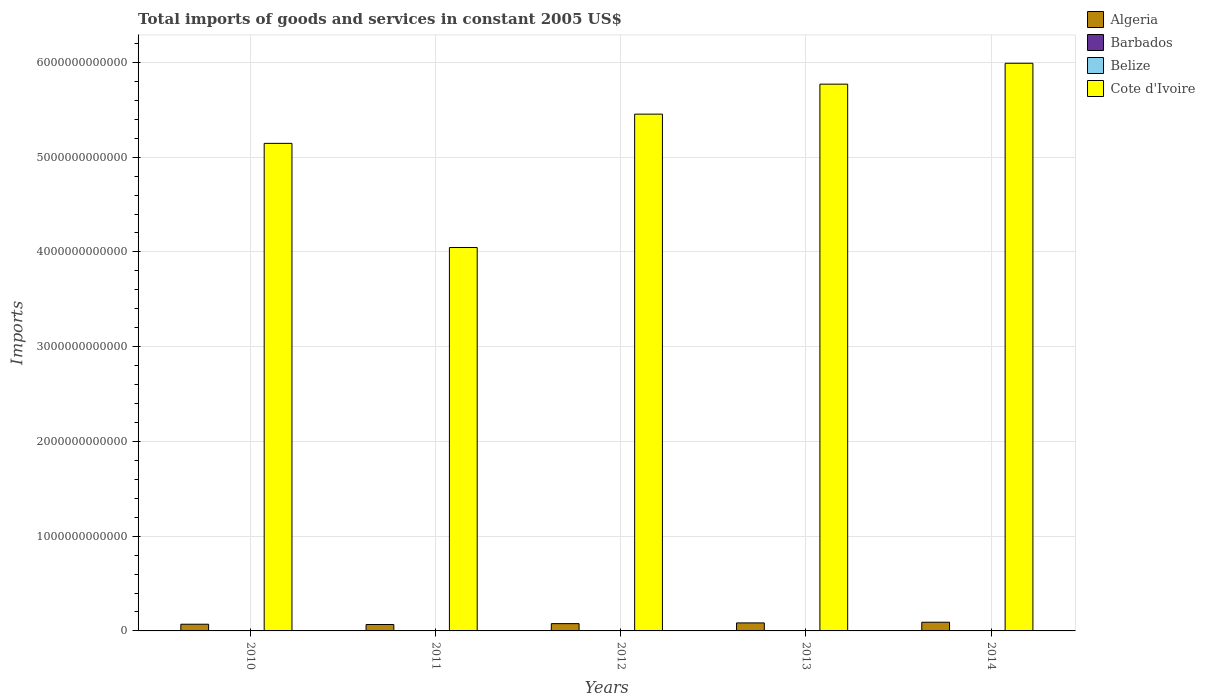How many groups of bars are there?
Keep it short and to the point. 5. Are the number of bars per tick equal to the number of legend labels?
Your answer should be very brief. Yes. Are the number of bars on each tick of the X-axis equal?
Make the answer very short. Yes. How many bars are there on the 3rd tick from the right?
Provide a succinct answer. 4. What is the label of the 5th group of bars from the left?
Your response must be concise. 2014. What is the total imports of goods and services in Algeria in 2012?
Give a very brief answer. 7.68e+1. Across all years, what is the maximum total imports of goods and services in Cote d'Ivoire?
Offer a very short reply. 5.99e+12. Across all years, what is the minimum total imports of goods and services in Barbados?
Offer a very short reply. 5.64e+08. In which year was the total imports of goods and services in Algeria maximum?
Keep it short and to the point. 2014. What is the total total imports of goods and services in Cote d'Ivoire in the graph?
Provide a succinct answer. 2.64e+13. What is the difference between the total imports of goods and services in Cote d'Ivoire in 2010 and that in 2014?
Keep it short and to the point. -8.46e+11. What is the difference between the total imports of goods and services in Algeria in 2010 and the total imports of goods and services in Barbados in 2013?
Your answer should be compact. 7.02e+1. What is the average total imports of goods and services in Algeria per year?
Keep it short and to the point. 7.83e+1. In the year 2014, what is the difference between the total imports of goods and services in Algeria and total imports of goods and services in Barbados?
Give a very brief answer. 9.12e+1. In how many years, is the total imports of goods and services in Cote d'Ivoire greater than 5800000000000 US$?
Make the answer very short. 1. What is the ratio of the total imports of goods and services in Belize in 2010 to that in 2014?
Offer a very short reply. 0.77. Is the difference between the total imports of goods and services in Algeria in 2012 and 2014 greater than the difference between the total imports of goods and services in Barbados in 2012 and 2014?
Provide a succinct answer. No. What is the difference between the highest and the second highest total imports of goods and services in Belize?
Offer a terse response. 1.65e+07. What is the difference between the highest and the lowest total imports of goods and services in Barbados?
Provide a succinct answer. 1.12e+08. In how many years, is the total imports of goods and services in Belize greater than the average total imports of goods and services in Belize taken over all years?
Ensure brevity in your answer.  2. Is it the case that in every year, the sum of the total imports of goods and services in Cote d'Ivoire and total imports of goods and services in Belize is greater than the sum of total imports of goods and services in Barbados and total imports of goods and services in Algeria?
Provide a short and direct response. Yes. What does the 1st bar from the left in 2011 represents?
Ensure brevity in your answer.  Algeria. What does the 3rd bar from the right in 2014 represents?
Provide a succinct answer. Barbados. Is it the case that in every year, the sum of the total imports of goods and services in Algeria and total imports of goods and services in Barbados is greater than the total imports of goods and services in Belize?
Provide a succinct answer. Yes. How many bars are there?
Your answer should be compact. 20. Are all the bars in the graph horizontal?
Provide a short and direct response. No. What is the difference between two consecutive major ticks on the Y-axis?
Offer a very short reply. 1.00e+12. Does the graph contain grids?
Make the answer very short. Yes. Where does the legend appear in the graph?
Provide a short and direct response. Top right. How are the legend labels stacked?
Your answer should be compact. Vertical. What is the title of the graph?
Your response must be concise. Total imports of goods and services in constant 2005 US$. What is the label or title of the X-axis?
Make the answer very short. Years. What is the label or title of the Y-axis?
Your answer should be compact. Imports. What is the Imports of Algeria in 2010?
Your answer should be very brief. 7.07e+1. What is the Imports in Barbados in 2010?
Make the answer very short. 6.76e+08. What is the Imports in Belize in 2010?
Your answer should be very brief. 1.25e+09. What is the Imports of Cote d'Ivoire in 2010?
Keep it short and to the point. 5.15e+12. What is the Imports of Algeria in 2011?
Ensure brevity in your answer.  6.75e+1. What is the Imports of Barbados in 2011?
Provide a succinct answer. 5.96e+08. What is the Imports of Belize in 2011?
Ensure brevity in your answer.  1.39e+09. What is the Imports in Cote d'Ivoire in 2011?
Provide a short and direct response. 4.05e+12. What is the Imports in Algeria in 2012?
Offer a very short reply. 7.68e+1. What is the Imports of Barbados in 2012?
Make the answer very short. 5.68e+08. What is the Imports of Belize in 2012?
Ensure brevity in your answer.  1.45e+09. What is the Imports in Cote d'Ivoire in 2012?
Make the answer very short. 5.45e+12. What is the Imports in Algeria in 2013?
Keep it short and to the point. 8.45e+1. What is the Imports of Barbados in 2013?
Your answer should be very brief. 5.64e+08. What is the Imports of Belize in 2013?
Your answer should be very brief. 1.60e+09. What is the Imports of Cote d'Ivoire in 2013?
Your answer should be very brief. 5.77e+12. What is the Imports in Algeria in 2014?
Keep it short and to the point. 9.18e+1. What is the Imports of Barbados in 2014?
Your response must be concise. 5.75e+08. What is the Imports of Belize in 2014?
Your response must be concise. 1.61e+09. What is the Imports of Cote d'Ivoire in 2014?
Provide a succinct answer. 5.99e+12. Across all years, what is the maximum Imports in Algeria?
Offer a terse response. 9.18e+1. Across all years, what is the maximum Imports of Barbados?
Ensure brevity in your answer.  6.76e+08. Across all years, what is the maximum Imports in Belize?
Keep it short and to the point. 1.61e+09. Across all years, what is the maximum Imports of Cote d'Ivoire?
Make the answer very short. 5.99e+12. Across all years, what is the minimum Imports of Algeria?
Offer a very short reply. 6.75e+1. Across all years, what is the minimum Imports in Barbados?
Give a very brief answer. 5.64e+08. Across all years, what is the minimum Imports of Belize?
Keep it short and to the point. 1.25e+09. Across all years, what is the minimum Imports of Cote d'Ivoire?
Your answer should be very brief. 4.05e+12. What is the total Imports in Algeria in the graph?
Your answer should be very brief. 3.91e+11. What is the total Imports of Barbados in the graph?
Your answer should be compact. 2.98e+09. What is the total Imports in Belize in the graph?
Your answer should be very brief. 7.30e+09. What is the total Imports in Cote d'Ivoire in the graph?
Give a very brief answer. 2.64e+13. What is the difference between the Imports of Algeria in 2010 and that in 2011?
Provide a short and direct response. 3.25e+09. What is the difference between the Imports of Barbados in 2010 and that in 2011?
Offer a very short reply. 8.00e+07. What is the difference between the Imports of Belize in 2010 and that in 2011?
Offer a terse response. -1.47e+08. What is the difference between the Imports in Cote d'Ivoire in 2010 and that in 2011?
Give a very brief answer. 1.10e+12. What is the difference between the Imports in Algeria in 2010 and that in 2012?
Your answer should be compact. -6.12e+09. What is the difference between the Imports of Barbados in 2010 and that in 2012?
Your answer should be compact. 1.08e+08. What is the difference between the Imports in Belize in 2010 and that in 2012?
Your answer should be very brief. -2.09e+08. What is the difference between the Imports of Cote d'Ivoire in 2010 and that in 2012?
Give a very brief answer. -3.09e+11. What is the difference between the Imports of Algeria in 2010 and that in 2013?
Keep it short and to the point. -1.38e+1. What is the difference between the Imports in Barbados in 2010 and that in 2013?
Provide a succinct answer. 1.12e+08. What is the difference between the Imports in Belize in 2010 and that in 2013?
Offer a terse response. -3.49e+08. What is the difference between the Imports in Cote d'Ivoire in 2010 and that in 2013?
Your response must be concise. -6.25e+11. What is the difference between the Imports of Algeria in 2010 and that in 2014?
Offer a terse response. -2.11e+1. What is the difference between the Imports of Barbados in 2010 and that in 2014?
Keep it short and to the point. 1.01e+08. What is the difference between the Imports of Belize in 2010 and that in 2014?
Your answer should be very brief. -3.66e+08. What is the difference between the Imports of Cote d'Ivoire in 2010 and that in 2014?
Your answer should be very brief. -8.46e+11. What is the difference between the Imports of Algeria in 2011 and that in 2012?
Provide a short and direct response. -9.38e+09. What is the difference between the Imports of Barbados in 2011 and that in 2012?
Your answer should be compact. 2.80e+07. What is the difference between the Imports of Belize in 2011 and that in 2012?
Your answer should be very brief. -6.25e+07. What is the difference between the Imports of Cote d'Ivoire in 2011 and that in 2012?
Your response must be concise. -1.41e+12. What is the difference between the Imports of Algeria in 2011 and that in 2013?
Provide a short and direct response. -1.71e+1. What is the difference between the Imports in Barbados in 2011 and that in 2013?
Ensure brevity in your answer.  3.20e+07. What is the difference between the Imports of Belize in 2011 and that in 2013?
Offer a terse response. -2.03e+08. What is the difference between the Imports of Cote d'Ivoire in 2011 and that in 2013?
Offer a terse response. -1.72e+12. What is the difference between the Imports in Algeria in 2011 and that in 2014?
Your response must be concise. -2.43e+1. What is the difference between the Imports in Barbados in 2011 and that in 2014?
Keep it short and to the point. 2.10e+07. What is the difference between the Imports of Belize in 2011 and that in 2014?
Your answer should be compact. -2.19e+08. What is the difference between the Imports in Cote d'Ivoire in 2011 and that in 2014?
Make the answer very short. -1.94e+12. What is the difference between the Imports in Algeria in 2012 and that in 2013?
Offer a very short reply. -7.68e+09. What is the difference between the Imports of Barbados in 2012 and that in 2013?
Offer a terse response. 4.00e+06. What is the difference between the Imports in Belize in 2012 and that in 2013?
Offer a very short reply. -1.40e+08. What is the difference between the Imports in Cote d'Ivoire in 2012 and that in 2013?
Provide a succinct answer. -3.16e+11. What is the difference between the Imports in Algeria in 2012 and that in 2014?
Provide a succinct answer. -1.50e+1. What is the difference between the Imports of Barbados in 2012 and that in 2014?
Offer a terse response. -7.00e+06. What is the difference between the Imports of Belize in 2012 and that in 2014?
Offer a very short reply. -1.57e+08. What is the difference between the Imports in Cote d'Ivoire in 2012 and that in 2014?
Provide a succinct answer. -5.37e+11. What is the difference between the Imports in Algeria in 2013 and that in 2014?
Make the answer very short. -7.27e+09. What is the difference between the Imports of Barbados in 2013 and that in 2014?
Your response must be concise. -1.10e+07. What is the difference between the Imports in Belize in 2013 and that in 2014?
Make the answer very short. -1.65e+07. What is the difference between the Imports in Cote d'Ivoire in 2013 and that in 2014?
Your response must be concise. -2.21e+11. What is the difference between the Imports in Algeria in 2010 and the Imports in Barbados in 2011?
Offer a terse response. 7.01e+1. What is the difference between the Imports of Algeria in 2010 and the Imports of Belize in 2011?
Make the answer very short. 6.93e+1. What is the difference between the Imports in Algeria in 2010 and the Imports in Cote d'Ivoire in 2011?
Offer a terse response. -3.98e+12. What is the difference between the Imports of Barbados in 2010 and the Imports of Belize in 2011?
Offer a terse response. -7.16e+08. What is the difference between the Imports in Barbados in 2010 and the Imports in Cote d'Ivoire in 2011?
Your answer should be compact. -4.05e+12. What is the difference between the Imports in Belize in 2010 and the Imports in Cote d'Ivoire in 2011?
Offer a very short reply. -4.05e+12. What is the difference between the Imports of Algeria in 2010 and the Imports of Barbados in 2012?
Make the answer very short. 7.02e+1. What is the difference between the Imports of Algeria in 2010 and the Imports of Belize in 2012?
Your response must be concise. 6.93e+1. What is the difference between the Imports in Algeria in 2010 and the Imports in Cote d'Ivoire in 2012?
Your answer should be very brief. -5.38e+12. What is the difference between the Imports in Barbados in 2010 and the Imports in Belize in 2012?
Offer a terse response. -7.79e+08. What is the difference between the Imports of Barbados in 2010 and the Imports of Cote d'Ivoire in 2012?
Make the answer very short. -5.45e+12. What is the difference between the Imports of Belize in 2010 and the Imports of Cote d'Ivoire in 2012?
Your response must be concise. -5.45e+12. What is the difference between the Imports in Algeria in 2010 and the Imports in Barbados in 2013?
Keep it short and to the point. 7.02e+1. What is the difference between the Imports of Algeria in 2010 and the Imports of Belize in 2013?
Offer a very short reply. 6.91e+1. What is the difference between the Imports of Algeria in 2010 and the Imports of Cote d'Ivoire in 2013?
Your answer should be compact. -5.70e+12. What is the difference between the Imports in Barbados in 2010 and the Imports in Belize in 2013?
Your response must be concise. -9.19e+08. What is the difference between the Imports of Barbados in 2010 and the Imports of Cote d'Ivoire in 2013?
Your response must be concise. -5.77e+12. What is the difference between the Imports in Belize in 2010 and the Imports in Cote d'Ivoire in 2013?
Provide a short and direct response. -5.77e+12. What is the difference between the Imports in Algeria in 2010 and the Imports in Barbados in 2014?
Keep it short and to the point. 7.01e+1. What is the difference between the Imports of Algeria in 2010 and the Imports of Belize in 2014?
Your answer should be very brief. 6.91e+1. What is the difference between the Imports of Algeria in 2010 and the Imports of Cote d'Ivoire in 2014?
Your answer should be very brief. -5.92e+12. What is the difference between the Imports in Barbados in 2010 and the Imports in Belize in 2014?
Offer a very short reply. -9.36e+08. What is the difference between the Imports in Barbados in 2010 and the Imports in Cote d'Ivoire in 2014?
Your answer should be very brief. -5.99e+12. What is the difference between the Imports of Belize in 2010 and the Imports of Cote d'Ivoire in 2014?
Your answer should be very brief. -5.99e+12. What is the difference between the Imports in Algeria in 2011 and the Imports in Barbados in 2012?
Provide a succinct answer. 6.69e+1. What is the difference between the Imports of Algeria in 2011 and the Imports of Belize in 2012?
Offer a terse response. 6.60e+1. What is the difference between the Imports of Algeria in 2011 and the Imports of Cote d'Ivoire in 2012?
Offer a terse response. -5.39e+12. What is the difference between the Imports in Barbados in 2011 and the Imports in Belize in 2012?
Keep it short and to the point. -8.59e+08. What is the difference between the Imports in Barbados in 2011 and the Imports in Cote d'Ivoire in 2012?
Give a very brief answer. -5.45e+12. What is the difference between the Imports of Belize in 2011 and the Imports of Cote d'Ivoire in 2012?
Give a very brief answer. -5.45e+12. What is the difference between the Imports of Algeria in 2011 and the Imports of Barbados in 2013?
Keep it short and to the point. 6.69e+1. What is the difference between the Imports in Algeria in 2011 and the Imports in Belize in 2013?
Ensure brevity in your answer.  6.59e+1. What is the difference between the Imports of Algeria in 2011 and the Imports of Cote d'Ivoire in 2013?
Offer a terse response. -5.70e+12. What is the difference between the Imports in Barbados in 2011 and the Imports in Belize in 2013?
Your answer should be very brief. -9.99e+08. What is the difference between the Imports of Barbados in 2011 and the Imports of Cote d'Ivoire in 2013?
Your response must be concise. -5.77e+12. What is the difference between the Imports of Belize in 2011 and the Imports of Cote d'Ivoire in 2013?
Give a very brief answer. -5.77e+12. What is the difference between the Imports of Algeria in 2011 and the Imports of Barbados in 2014?
Your answer should be very brief. 6.69e+1. What is the difference between the Imports in Algeria in 2011 and the Imports in Belize in 2014?
Provide a short and direct response. 6.59e+1. What is the difference between the Imports of Algeria in 2011 and the Imports of Cote d'Ivoire in 2014?
Ensure brevity in your answer.  -5.92e+12. What is the difference between the Imports of Barbados in 2011 and the Imports of Belize in 2014?
Give a very brief answer. -1.02e+09. What is the difference between the Imports of Barbados in 2011 and the Imports of Cote d'Ivoire in 2014?
Give a very brief answer. -5.99e+12. What is the difference between the Imports in Belize in 2011 and the Imports in Cote d'Ivoire in 2014?
Make the answer very short. -5.99e+12. What is the difference between the Imports of Algeria in 2012 and the Imports of Barbados in 2013?
Offer a very short reply. 7.63e+1. What is the difference between the Imports of Algeria in 2012 and the Imports of Belize in 2013?
Your response must be concise. 7.52e+1. What is the difference between the Imports in Algeria in 2012 and the Imports in Cote d'Ivoire in 2013?
Offer a very short reply. -5.69e+12. What is the difference between the Imports of Barbados in 2012 and the Imports of Belize in 2013?
Your answer should be very brief. -1.03e+09. What is the difference between the Imports in Barbados in 2012 and the Imports in Cote d'Ivoire in 2013?
Make the answer very short. -5.77e+12. What is the difference between the Imports in Belize in 2012 and the Imports in Cote d'Ivoire in 2013?
Offer a terse response. -5.77e+12. What is the difference between the Imports of Algeria in 2012 and the Imports of Barbados in 2014?
Provide a short and direct response. 7.63e+1. What is the difference between the Imports in Algeria in 2012 and the Imports in Belize in 2014?
Your answer should be compact. 7.52e+1. What is the difference between the Imports of Algeria in 2012 and the Imports of Cote d'Ivoire in 2014?
Your response must be concise. -5.91e+12. What is the difference between the Imports in Barbados in 2012 and the Imports in Belize in 2014?
Offer a terse response. -1.04e+09. What is the difference between the Imports in Barbados in 2012 and the Imports in Cote d'Ivoire in 2014?
Provide a short and direct response. -5.99e+12. What is the difference between the Imports of Belize in 2012 and the Imports of Cote d'Ivoire in 2014?
Your answer should be very brief. -5.99e+12. What is the difference between the Imports in Algeria in 2013 and the Imports in Barbados in 2014?
Your answer should be compact. 8.40e+1. What is the difference between the Imports in Algeria in 2013 and the Imports in Belize in 2014?
Ensure brevity in your answer.  8.29e+1. What is the difference between the Imports of Algeria in 2013 and the Imports of Cote d'Ivoire in 2014?
Keep it short and to the point. -5.91e+12. What is the difference between the Imports of Barbados in 2013 and the Imports of Belize in 2014?
Your answer should be compact. -1.05e+09. What is the difference between the Imports of Barbados in 2013 and the Imports of Cote d'Ivoire in 2014?
Provide a succinct answer. -5.99e+12. What is the difference between the Imports in Belize in 2013 and the Imports in Cote d'Ivoire in 2014?
Offer a terse response. -5.99e+12. What is the average Imports of Algeria per year?
Your response must be concise. 7.83e+1. What is the average Imports in Barbados per year?
Offer a terse response. 5.96e+08. What is the average Imports in Belize per year?
Provide a succinct answer. 1.46e+09. What is the average Imports of Cote d'Ivoire per year?
Your answer should be very brief. 5.28e+12. In the year 2010, what is the difference between the Imports of Algeria and Imports of Barbados?
Provide a short and direct response. 7.00e+1. In the year 2010, what is the difference between the Imports of Algeria and Imports of Belize?
Your answer should be compact. 6.95e+1. In the year 2010, what is the difference between the Imports of Algeria and Imports of Cote d'Ivoire?
Your answer should be very brief. -5.07e+12. In the year 2010, what is the difference between the Imports in Barbados and Imports in Belize?
Your answer should be compact. -5.70e+08. In the year 2010, what is the difference between the Imports of Barbados and Imports of Cote d'Ivoire?
Offer a very short reply. -5.14e+12. In the year 2010, what is the difference between the Imports in Belize and Imports in Cote d'Ivoire?
Offer a terse response. -5.14e+12. In the year 2011, what is the difference between the Imports in Algeria and Imports in Barbados?
Offer a terse response. 6.69e+1. In the year 2011, what is the difference between the Imports of Algeria and Imports of Belize?
Keep it short and to the point. 6.61e+1. In the year 2011, what is the difference between the Imports of Algeria and Imports of Cote d'Ivoire?
Provide a short and direct response. -3.98e+12. In the year 2011, what is the difference between the Imports of Barbados and Imports of Belize?
Offer a very short reply. -7.96e+08. In the year 2011, what is the difference between the Imports of Barbados and Imports of Cote d'Ivoire?
Offer a very short reply. -4.05e+12. In the year 2011, what is the difference between the Imports in Belize and Imports in Cote d'Ivoire?
Your answer should be compact. -4.04e+12. In the year 2012, what is the difference between the Imports in Algeria and Imports in Barbados?
Your response must be concise. 7.63e+1. In the year 2012, what is the difference between the Imports of Algeria and Imports of Belize?
Ensure brevity in your answer.  7.54e+1. In the year 2012, what is the difference between the Imports in Algeria and Imports in Cote d'Ivoire?
Offer a terse response. -5.38e+12. In the year 2012, what is the difference between the Imports in Barbados and Imports in Belize?
Give a very brief answer. -8.87e+08. In the year 2012, what is the difference between the Imports in Barbados and Imports in Cote d'Ivoire?
Provide a short and direct response. -5.45e+12. In the year 2012, what is the difference between the Imports in Belize and Imports in Cote d'Ivoire?
Provide a succinct answer. -5.45e+12. In the year 2013, what is the difference between the Imports of Algeria and Imports of Barbados?
Provide a succinct answer. 8.40e+1. In the year 2013, what is the difference between the Imports in Algeria and Imports in Belize?
Your answer should be compact. 8.29e+1. In the year 2013, what is the difference between the Imports in Algeria and Imports in Cote d'Ivoire?
Make the answer very short. -5.69e+12. In the year 2013, what is the difference between the Imports of Barbados and Imports of Belize?
Your answer should be compact. -1.03e+09. In the year 2013, what is the difference between the Imports in Barbados and Imports in Cote d'Ivoire?
Ensure brevity in your answer.  -5.77e+12. In the year 2013, what is the difference between the Imports of Belize and Imports of Cote d'Ivoire?
Offer a very short reply. -5.77e+12. In the year 2014, what is the difference between the Imports of Algeria and Imports of Barbados?
Offer a very short reply. 9.12e+1. In the year 2014, what is the difference between the Imports in Algeria and Imports in Belize?
Give a very brief answer. 9.02e+1. In the year 2014, what is the difference between the Imports in Algeria and Imports in Cote d'Ivoire?
Your answer should be compact. -5.90e+12. In the year 2014, what is the difference between the Imports of Barbados and Imports of Belize?
Your answer should be very brief. -1.04e+09. In the year 2014, what is the difference between the Imports of Barbados and Imports of Cote d'Ivoire?
Offer a terse response. -5.99e+12. In the year 2014, what is the difference between the Imports of Belize and Imports of Cote d'Ivoire?
Provide a succinct answer. -5.99e+12. What is the ratio of the Imports in Algeria in 2010 to that in 2011?
Keep it short and to the point. 1.05. What is the ratio of the Imports of Barbados in 2010 to that in 2011?
Ensure brevity in your answer.  1.13. What is the ratio of the Imports in Belize in 2010 to that in 2011?
Your response must be concise. 0.89. What is the ratio of the Imports in Cote d'Ivoire in 2010 to that in 2011?
Make the answer very short. 1.27. What is the ratio of the Imports in Algeria in 2010 to that in 2012?
Make the answer very short. 0.92. What is the ratio of the Imports in Barbados in 2010 to that in 2012?
Your answer should be compact. 1.19. What is the ratio of the Imports in Belize in 2010 to that in 2012?
Offer a terse response. 0.86. What is the ratio of the Imports in Cote d'Ivoire in 2010 to that in 2012?
Offer a terse response. 0.94. What is the ratio of the Imports of Algeria in 2010 to that in 2013?
Make the answer very short. 0.84. What is the ratio of the Imports in Barbados in 2010 to that in 2013?
Give a very brief answer. 1.2. What is the ratio of the Imports in Belize in 2010 to that in 2013?
Offer a terse response. 0.78. What is the ratio of the Imports of Cote d'Ivoire in 2010 to that in 2013?
Offer a terse response. 0.89. What is the ratio of the Imports of Algeria in 2010 to that in 2014?
Give a very brief answer. 0.77. What is the ratio of the Imports of Barbados in 2010 to that in 2014?
Provide a succinct answer. 1.18. What is the ratio of the Imports of Belize in 2010 to that in 2014?
Provide a succinct answer. 0.77. What is the ratio of the Imports of Cote d'Ivoire in 2010 to that in 2014?
Give a very brief answer. 0.86. What is the ratio of the Imports of Algeria in 2011 to that in 2012?
Offer a very short reply. 0.88. What is the ratio of the Imports of Barbados in 2011 to that in 2012?
Give a very brief answer. 1.05. What is the ratio of the Imports in Belize in 2011 to that in 2012?
Give a very brief answer. 0.96. What is the ratio of the Imports of Cote d'Ivoire in 2011 to that in 2012?
Give a very brief answer. 0.74. What is the ratio of the Imports of Algeria in 2011 to that in 2013?
Provide a short and direct response. 0.8. What is the ratio of the Imports in Barbados in 2011 to that in 2013?
Your answer should be very brief. 1.06. What is the ratio of the Imports in Belize in 2011 to that in 2013?
Give a very brief answer. 0.87. What is the ratio of the Imports in Cote d'Ivoire in 2011 to that in 2013?
Offer a very short reply. 0.7. What is the ratio of the Imports in Algeria in 2011 to that in 2014?
Provide a short and direct response. 0.73. What is the ratio of the Imports of Barbados in 2011 to that in 2014?
Provide a succinct answer. 1.04. What is the ratio of the Imports in Belize in 2011 to that in 2014?
Your response must be concise. 0.86. What is the ratio of the Imports in Cote d'Ivoire in 2011 to that in 2014?
Keep it short and to the point. 0.68. What is the ratio of the Imports of Barbados in 2012 to that in 2013?
Offer a very short reply. 1.01. What is the ratio of the Imports of Belize in 2012 to that in 2013?
Your response must be concise. 0.91. What is the ratio of the Imports of Cote d'Ivoire in 2012 to that in 2013?
Your response must be concise. 0.95. What is the ratio of the Imports in Algeria in 2012 to that in 2014?
Offer a very short reply. 0.84. What is the ratio of the Imports of Barbados in 2012 to that in 2014?
Ensure brevity in your answer.  0.99. What is the ratio of the Imports of Belize in 2012 to that in 2014?
Your response must be concise. 0.9. What is the ratio of the Imports of Cote d'Ivoire in 2012 to that in 2014?
Offer a terse response. 0.91. What is the ratio of the Imports of Algeria in 2013 to that in 2014?
Keep it short and to the point. 0.92. What is the ratio of the Imports in Barbados in 2013 to that in 2014?
Your answer should be very brief. 0.98. What is the ratio of the Imports of Cote d'Ivoire in 2013 to that in 2014?
Ensure brevity in your answer.  0.96. What is the difference between the highest and the second highest Imports in Algeria?
Make the answer very short. 7.27e+09. What is the difference between the highest and the second highest Imports of Barbados?
Your answer should be very brief. 8.00e+07. What is the difference between the highest and the second highest Imports in Belize?
Provide a succinct answer. 1.65e+07. What is the difference between the highest and the second highest Imports in Cote d'Ivoire?
Make the answer very short. 2.21e+11. What is the difference between the highest and the lowest Imports in Algeria?
Give a very brief answer. 2.43e+1. What is the difference between the highest and the lowest Imports in Barbados?
Offer a very short reply. 1.12e+08. What is the difference between the highest and the lowest Imports in Belize?
Make the answer very short. 3.66e+08. What is the difference between the highest and the lowest Imports in Cote d'Ivoire?
Offer a very short reply. 1.94e+12. 